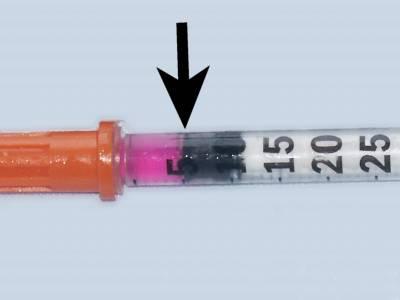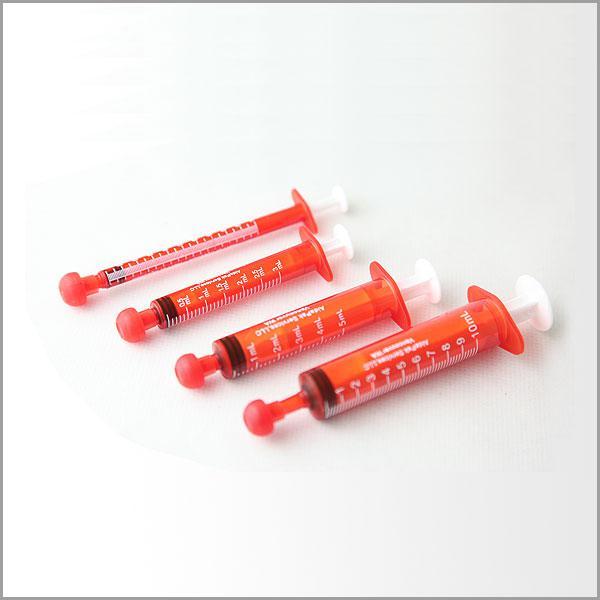The first image is the image on the left, the second image is the image on the right. For the images shown, is this caption "Atleast one of the images has 4 needles" true? Answer yes or no. Yes. The first image is the image on the left, the second image is the image on the right. Given the left and right images, does the statement "One of the images contains four syringes that appear to be red in color or fill." hold true? Answer yes or no. Yes. 